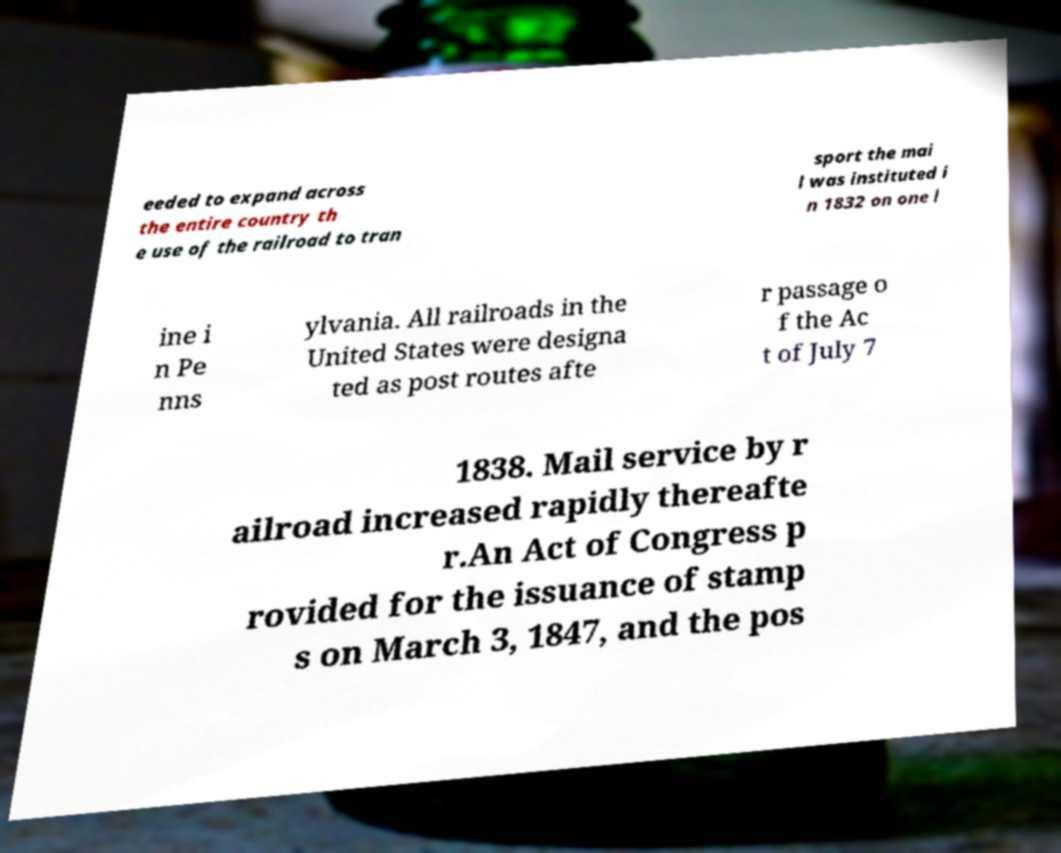Could you assist in decoding the text presented in this image and type it out clearly? eeded to expand across the entire country th e use of the railroad to tran sport the mai l was instituted i n 1832 on one l ine i n Pe nns ylvania. All railroads in the United States were designa ted as post routes afte r passage o f the Ac t of July 7 1838. Mail service by r ailroad increased rapidly thereafte r.An Act of Congress p rovided for the issuance of stamp s on March 3, 1847, and the pos 